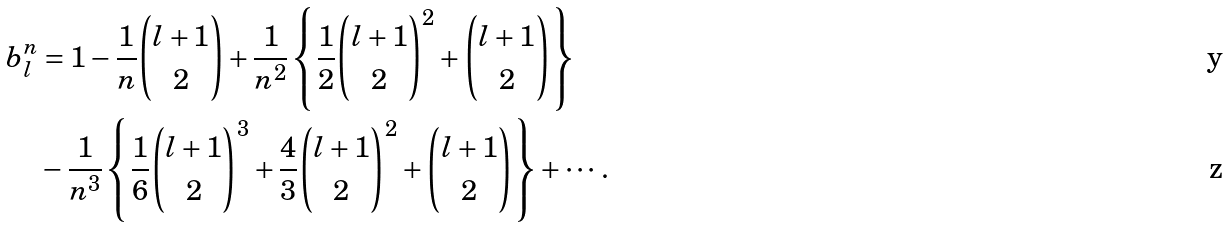Convert formula to latex. <formula><loc_0><loc_0><loc_500><loc_500>b _ { l } ^ { n } & = 1 - \frac { 1 } { n } \binom { l + 1 } { 2 } + \frac { 1 } { n ^ { 2 } } \left \{ \frac { 1 } { 2 } \binom { l + 1 } { 2 } ^ { 2 } + \binom { l + 1 } { 2 } \right \} \\ & - \frac { 1 } { n ^ { 3 } } \left \{ \frac { 1 } { 6 } \binom { l + 1 } { 2 } ^ { 3 } + \frac { 4 } { 3 } \binom { l + 1 } { 2 } ^ { 2 } + \binom { l + 1 } { 2 } \right \} + \cdots .</formula> 